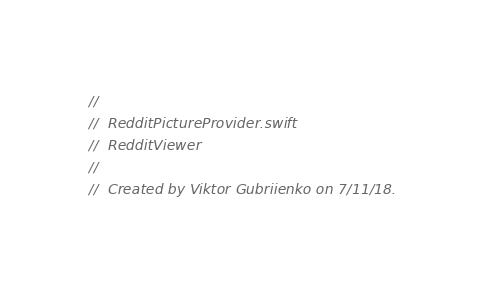Convert code to text. <code><loc_0><loc_0><loc_500><loc_500><_Swift_>//
//  RedditPictureProvider.swift
//  RedditViewer
//
//  Created by Viktor Gubriienko on 7/11/18.</code> 